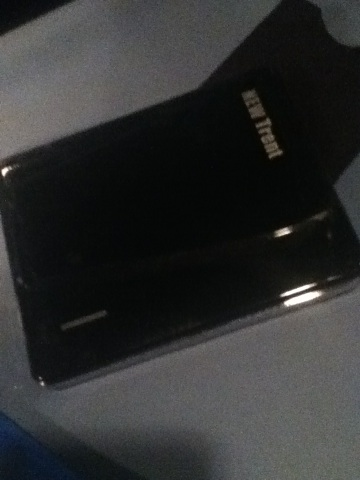Describe a scenario where this device plays a crucial role. The external hard drive plays a crucial role during a large-scale data migration process for a growing tech company. The team is tasked with transferring terabytes of data from old servers to a new, more efficient storage solution. Due to unforeseen issues, the data cannot be moved directly, and time is of the essence to prevent any loss. The team employs several high-capacity external hard drives to safely transfer data in manageable chunks, ultimately ensuring that the operation runs smoothly and business continuity is maintained without any data loss. 